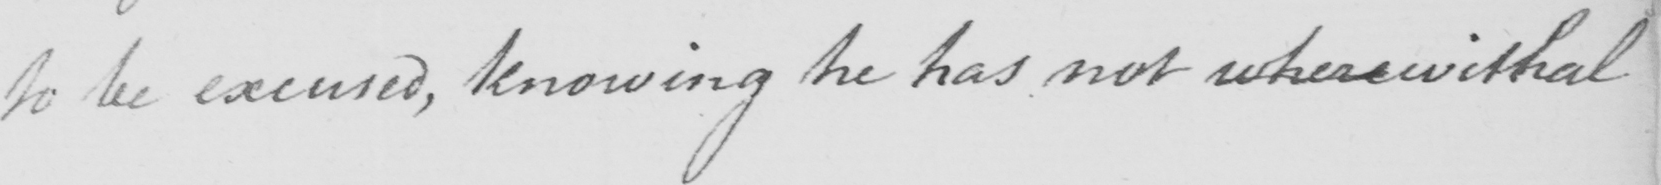Can you read and transcribe this handwriting? to be excused , knowing he has not wherewithal 